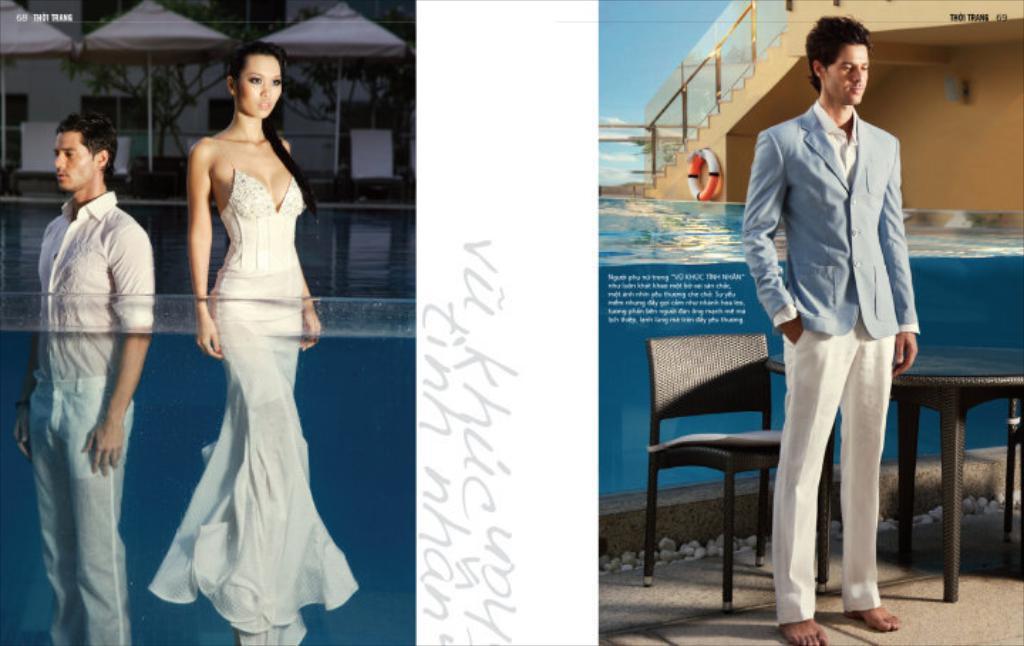In one or two sentences, can you explain what this image depicts? In this image I can see three persons standing. There is a table and chair. The person is wearing a blue blazer and a white pant. At the back side I can see a water,tube and a stairs and on the left side I can see a tent and a trees. There is a building. The woman is wearing a white fork. 